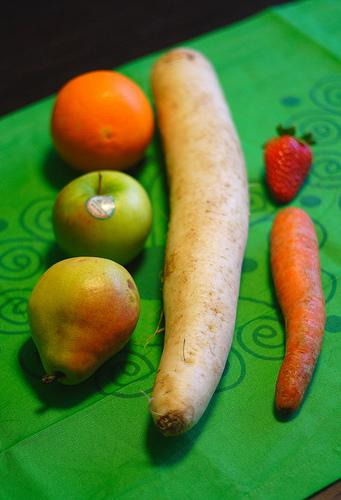Mention any visible labels or stickers on the fruits. There is a white and round label on the apple and a sticker on a green apple. Describe the scene in a poetic manner. A symphony of fruits and vegetables grace a tablecloth of green, adorned with swirls and circles, creating a feast for the eyes. What are the notable characteristics of the fruits and vegetables in the image? The strawberry is red, the carrot is orange, the pear is green and red, the apple is green with a sticker, and the orange is orange. Mention the types of fruits and vegetables found in the image. A pear, apple, orange, strawberry, and carrot are present in the scene, with some having visible labels or sizes. Provide a general overview of the image. The image displays an assortment of fruits and vegetables lying on a green patterned cloth, set on a dark wood table. Describe the table and tablecloth in the image. The table is a dark wood tabletop, and the tablecloth is green with circular designs, swirls, and green dots as part of the pattern. Describe the relationship between the fruits and vegetables in the image. The red strawberry is above the orange carrot, and the orange orange is above the green apple. Provide a brief description of the objects in the image. There are various fruits and vegetables on a green cloth with a circular design, placed on top of a dark wood table. Explain the condition of the pear and parsnip in the image. There is a bruise on the pear, while the parsnip has dirt and tiny roots on it. Give a detailed description of the cloth on the table. The cloth is light green with dark green swirl decorations, green dots, and circle designs. 